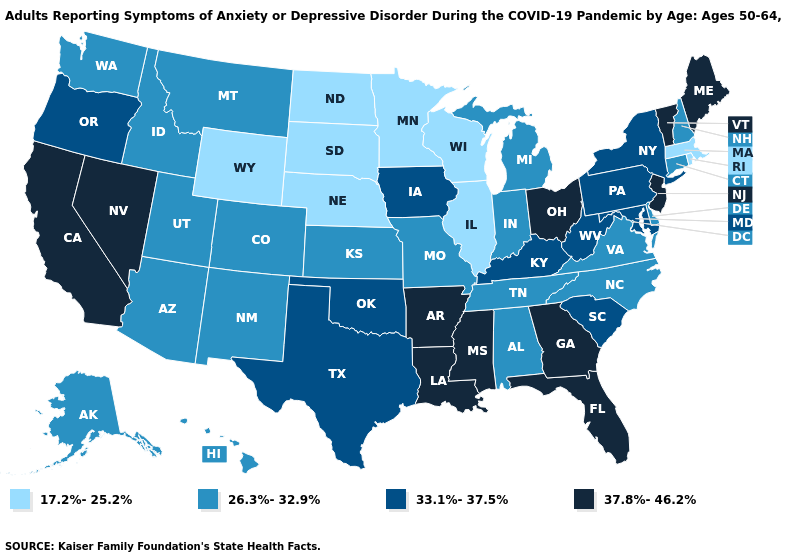What is the highest value in states that border Arizona?
Quick response, please. 37.8%-46.2%. Does Connecticut have the highest value in the Northeast?
Be succinct. No. Does the map have missing data?
Short answer required. No. What is the lowest value in states that border Louisiana?
Give a very brief answer. 33.1%-37.5%. What is the value of Texas?
Be succinct. 33.1%-37.5%. Does Florida have the lowest value in the USA?
Concise answer only. No. Name the states that have a value in the range 37.8%-46.2%?
Be succinct. Arkansas, California, Florida, Georgia, Louisiana, Maine, Mississippi, Nevada, New Jersey, Ohio, Vermont. Name the states that have a value in the range 17.2%-25.2%?
Answer briefly. Illinois, Massachusetts, Minnesota, Nebraska, North Dakota, Rhode Island, South Dakota, Wisconsin, Wyoming. What is the value of South Carolina?
Short answer required. 33.1%-37.5%. What is the value of New Jersey?
Be succinct. 37.8%-46.2%. Among the states that border North Carolina , does Georgia have the highest value?
Quick response, please. Yes. What is the value of Wisconsin?
Give a very brief answer. 17.2%-25.2%. What is the lowest value in the USA?
Quick response, please. 17.2%-25.2%. Name the states that have a value in the range 37.8%-46.2%?
Quick response, please. Arkansas, California, Florida, Georgia, Louisiana, Maine, Mississippi, Nevada, New Jersey, Ohio, Vermont. Name the states that have a value in the range 37.8%-46.2%?
Answer briefly. Arkansas, California, Florida, Georgia, Louisiana, Maine, Mississippi, Nevada, New Jersey, Ohio, Vermont. 